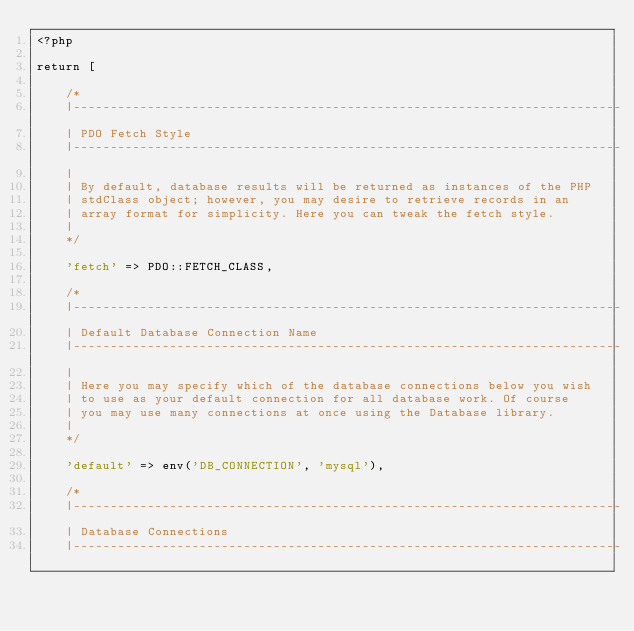<code> <loc_0><loc_0><loc_500><loc_500><_PHP_><?php

return [

    /*
    |--------------------------------------------------------------------------
    | PDO Fetch Style
    |--------------------------------------------------------------------------
    |
    | By default, database results will be returned as instances of the PHP
    | stdClass object; however, you may desire to retrieve records in an
    | array format for simplicity. Here you can tweak the fetch style.
    |
    */

    'fetch' => PDO::FETCH_CLASS,

    /*
    |--------------------------------------------------------------------------
    | Default Database Connection Name
    |--------------------------------------------------------------------------
    |
    | Here you may specify which of the database connections below you wish
    | to use as your default connection for all database work. Of course
    | you may use many connections at once using the Database library.
    |
    */

    'default' => env('DB_CONNECTION', 'mysql'),

    /*
    |--------------------------------------------------------------------------
    | Database Connections
    |--------------------------------------------------------------------------</code> 